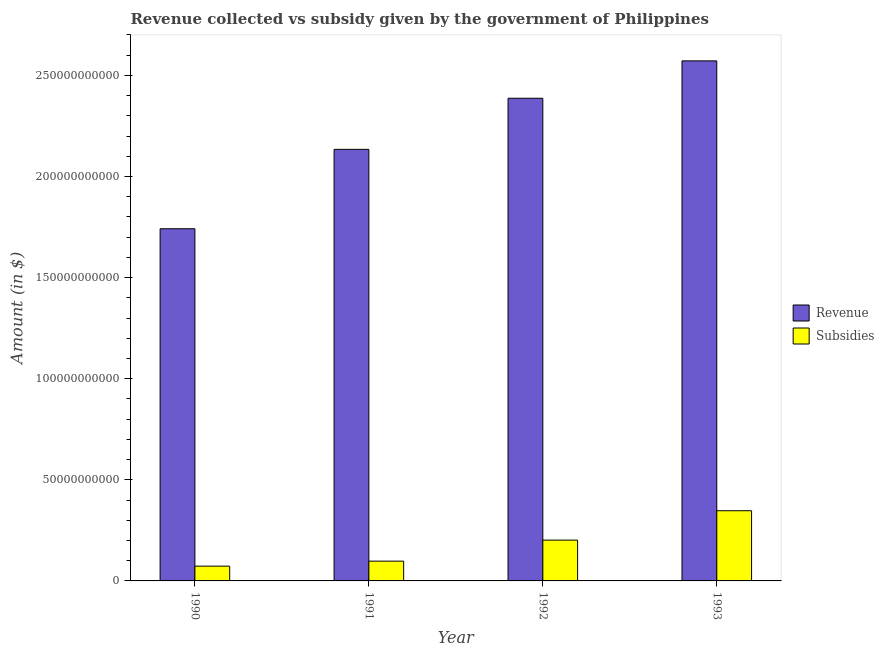How many different coloured bars are there?
Your response must be concise. 2. Are the number of bars per tick equal to the number of legend labels?
Keep it short and to the point. Yes. In how many cases, is the number of bars for a given year not equal to the number of legend labels?
Your answer should be very brief. 0. What is the amount of subsidies given in 1991?
Offer a very short reply. 9.78e+09. Across all years, what is the maximum amount of revenue collected?
Offer a terse response. 2.57e+11. Across all years, what is the minimum amount of subsidies given?
Your answer should be very brief. 7.31e+09. In which year was the amount of subsidies given maximum?
Your answer should be compact. 1993. What is the total amount of revenue collected in the graph?
Give a very brief answer. 8.83e+11. What is the difference between the amount of revenue collected in 1990 and that in 1993?
Your answer should be compact. -8.30e+1. What is the difference between the amount of subsidies given in 1991 and the amount of revenue collected in 1992?
Give a very brief answer. -1.04e+1. What is the average amount of revenue collected per year?
Your answer should be compact. 2.21e+11. What is the ratio of the amount of subsidies given in 1990 to that in 1992?
Your response must be concise. 0.36. Is the amount of subsidies given in 1990 less than that in 1991?
Keep it short and to the point. Yes. Is the difference between the amount of subsidies given in 1990 and 1993 greater than the difference between the amount of revenue collected in 1990 and 1993?
Offer a very short reply. No. What is the difference between the highest and the second highest amount of subsidies given?
Offer a very short reply. 1.45e+1. What is the difference between the highest and the lowest amount of subsidies given?
Keep it short and to the point. 2.74e+1. In how many years, is the amount of revenue collected greater than the average amount of revenue collected taken over all years?
Ensure brevity in your answer.  2. Is the sum of the amount of subsidies given in 1991 and 1993 greater than the maximum amount of revenue collected across all years?
Your answer should be very brief. Yes. What does the 1st bar from the left in 1991 represents?
Make the answer very short. Revenue. What does the 1st bar from the right in 1991 represents?
Your response must be concise. Subsidies. How many years are there in the graph?
Offer a very short reply. 4. What is the difference between two consecutive major ticks on the Y-axis?
Offer a terse response. 5.00e+1. Are the values on the major ticks of Y-axis written in scientific E-notation?
Ensure brevity in your answer.  No. How are the legend labels stacked?
Make the answer very short. Vertical. What is the title of the graph?
Provide a short and direct response. Revenue collected vs subsidy given by the government of Philippines. What is the label or title of the X-axis?
Give a very brief answer. Year. What is the label or title of the Y-axis?
Offer a terse response. Amount (in $). What is the Amount (in $) of Revenue in 1990?
Provide a succinct answer. 1.74e+11. What is the Amount (in $) of Subsidies in 1990?
Provide a succinct answer. 7.31e+09. What is the Amount (in $) of Revenue in 1991?
Keep it short and to the point. 2.13e+11. What is the Amount (in $) of Subsidies in 1991?
Provide a short and direct response. 9.78e+09. What is the Amount (in $) of Revenue in 1992?
Your response must be concise. 2.39e+11. What is the Amount (in $) in Subsidies in 1992?
Offer a terse response. 2.02e+1. What is the Amount (in $) of Revenue in 1993?
Offer a very short reply. 2.57e+11. What is the Amount (in $) in Subsidies in 1993?
Offer a terse response. 3.47e+1. Across all years, what is the maximum Amount (in $) in Revenue?
Ensure brevity in your answer.  2.57e+11. Across all years, what is the maximum Amount (in $) in Subsidies?
Give a very brief answer. 3.47e+1. Across all years, what is the minimum Amount (in $) of Revenue?
Keep it short and to the point. 1.74e+11. Across all years, what is the minimum Amount (in $) in Subsidies?
Offer a terse response. 7.31e+09. What is the total Amount (in $) in Revenue in the graph?
Your answer should be compact. 8.83e+11. What is the total Amount (in $) of Subsidies in the graph?
Give a very brief answer. 7.20e+1. What is the difference between the Amount (in $) in Revenue in 1990 and that in 1991?
Keep it short and to the point. -3.93e+1. What is the difference between the Amount (in $) of Subsidies in 1990 and that in 1991?
Provide a short and direct response. -2.47e+09. What is the difference between the Amount (in $) of Revenue in 1990 and that in 1992?
Ensure brevity in your answer.  -6.45e+1. What is the difference between the Amount (in $) in Subsidies in 1990 and that in 1992?
Give a very brief answer. -1.29e+1. What is the difference between the Amount (in $) of Revenue in 1990 and that in 1993?
Make the answer very short. -8.30e+1. What is the difference between the Amount (in $) of Subsidies in 1990 and that in 1993?
Make the answer very short. -2.74e+1. What is the difference between the Amount (in $) in Revenue in 1991 and that in 1992?
Your answer should be compact. -2.53e+1. What is the difference between the Amount (in $) of Subsidies in 1991 and that in 1992?
Offer a very short reply. -1.04e+1. What is the difference between the Amount (in $) of Revenue in 1991 and that in 1993?
Keep it short and to the point. -4.38e+1. What is the difference between the Amount (in $) in Subsidies in 1991 and that in 1993?
Provide a succinct answer. -2.49e+1. What is the difference between the Amount (in $) in Revenue in 1992 and that in 1993?
Keep it short and to the point. -1.85e+1. What is the difference between the Amount (in $) of Subsidies in 1992 and that in 1993?
Provide a succinct answer. -1.45e+1. What is the difference between the Amount (in $) of Revenue in 1990 and the Amount (in $) of Subsidies in 1991?
Provide a short and direct response. 1.64e+11. What is the difference between the Amount (in $) of Revenue in 1990 and the Amount (in $) of Subsidies in 1992?
Provide a succinct answer. 1.54e+11. What is the difference between the Amount (in $) in Revenue in 1990 and the Amount (in $) in Subsidies in 1993?
Your answer should be very brief. 1.39e+11. What is the difference between the Amount (in $) of Revenue in 1991 and the Amount (in $) of Subsidies in 1992?
Offer a terse response. 1.93e+11. What is the difference between the Amount (in $) in Revenue in 1991 and the Amount (in $) in Subsidies in 1993?
Provide a short and direct response. 1.79e+11. What is the difference between the Amount (in $) in Revenue in 1992 and the Amount (in $) in Subsidies in 1993?
Keep it short and to the point. 2.04e+11. What is the average Amount (in $) of Revenue per year?
Give a very brief answer. 2.21e+11. What is the average Amount (in $) in Subsidies per year?
Provide a succinct answer. 1.80e+1. In the year 1990, what is the difference between the Amount (in $) in Revenue and Amount (in $) in Subsidies?
Make the answer very short. 1.67e+11. In the year 1991, what is the difference between the Amount (in $) of Revenue and Amount (in $) of Subsidies?
Ensure brevity in your answer.  2.04e+11. In the year 1992, what is the difference between the Amount (in $) of Revenue and Amount (in $) of Subsidies?
Make the answer very short. 2.19e+11. In the year 1993, what is the difference between the Amount (in $) in Revenue and Amount (in $) in Subsidies?
Make the answer very short. 2.22e+11. What is the ratio of the Amount (in $) of Revenue in 1990 to that in 1991?
Ensure brevity in your answer.  0.82. What is the ratio of the Amount (in $) of Subsidies in 1990 to that in 1991?
Make the answer very short. 0.75. What is the ratio of the Amount (in $) in Revenue in 1990 to that in 1992?
Make the answer very short. 0.73. What is the ratio of the Amount (in $) in Subsidies in 1990 to that in 1992?
Offer a terse response. 0.36. What is the ratio of the Amount (in $) of Revenue in 1990 to that in 1993?
Provide a short and direct response. 0.68. What is the ratio of the Amount (in $) of Subsidies in 1990 to that in 1993?
Make the answer very short. 0.21. What is the ratio of the Amount (in $) of Revenue in 1991 to that in 1992?
Your response must be concise. 0.89. What is the ratio of the Amount (in $) of Subsidies in 1991 to that in 1992?
Your response must be concise. 0.48. What is the ratio of the Amount (in $) in Revenue in 1991 to that in 1993?
Offer a terse response. 0.83. What is the ratio of the Amount (in $) in Subsidies in 1991 to that in 1993?
Keep it short and to the point. 0.28. What is the ratio of the Amount (in $) of Revenue in 1992 to that in 1993?
Keep it short and to the point. 0.93. What is the ratio of the Amount (in $) in Subsidies in 1992 to that in 1993?
Give a very brief answer. 0.58. What is the difference between the highest and the second highest Amount (in $) in Revenue?
Your answer should be compact. 1.85e+1. What is the difference between the highest and the second highest Amount (in $) of Subsidies?
Ensure brevity in your answer.  1.45e+1. What is the difference between the highest and the lowest Amount (in $) of Revenue?
Give a very brief answer. 8.30e+1. What is the difference between the highest and the lowest Amount (in $) in Subsidies?
Offer a terse response. 2.74e+1. 